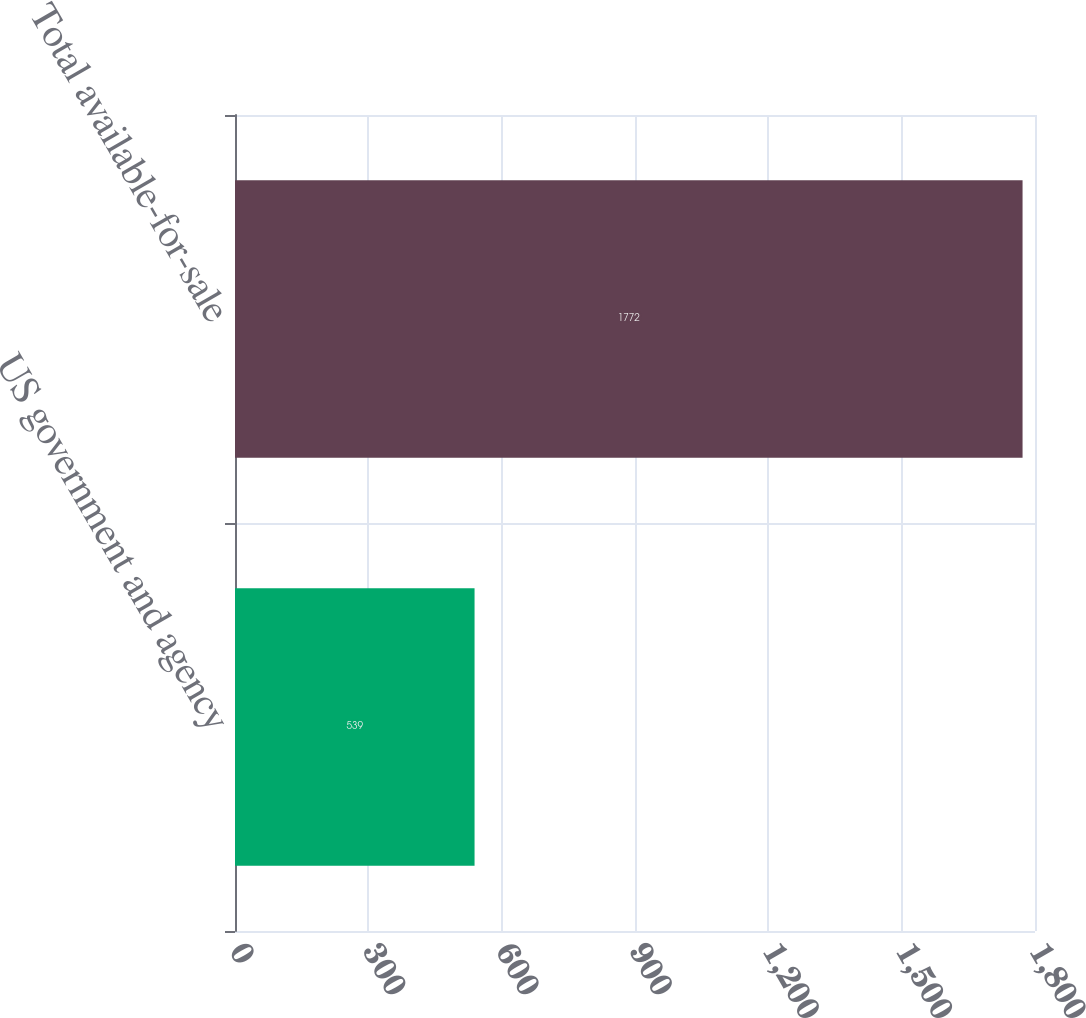Convert chart to OTSL. <chart><loc_0><loc_0><loc_500><loc_500><bar_chart><fcel>US government and agency<fcel>Total available-for-sale<nl><fcel>539<fcel>1772<nl></chart> 